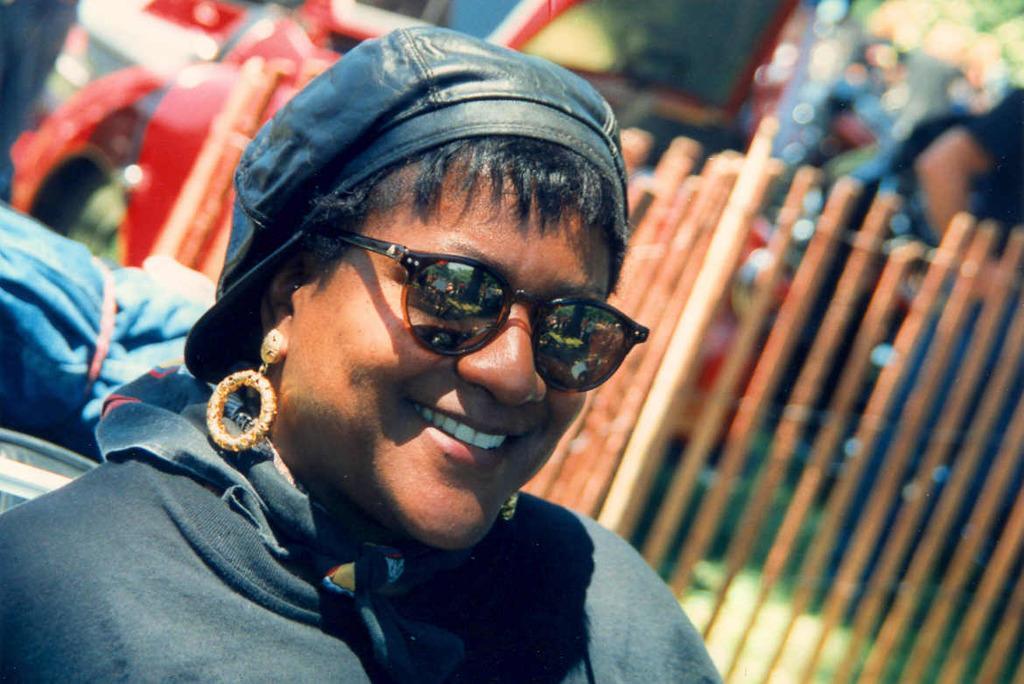Please provide a concise description of this image. In this image we can see a lady wearing jacket, cap, earrings and goggles, behind her there is an object, a fence, and the background is blurred. 